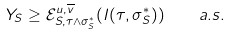<formula> <loc_0><loc_0><loc_500><loc_500>Y _ { S } \geq \mathcal { E } ^ { u , \overline { v } } _ { S , \tau \wedge \sigma _ { S } ^ { * } } ( I ( \tau , \sigma _ { S } ^ { * } ) ) \quad a . s .</formula> 